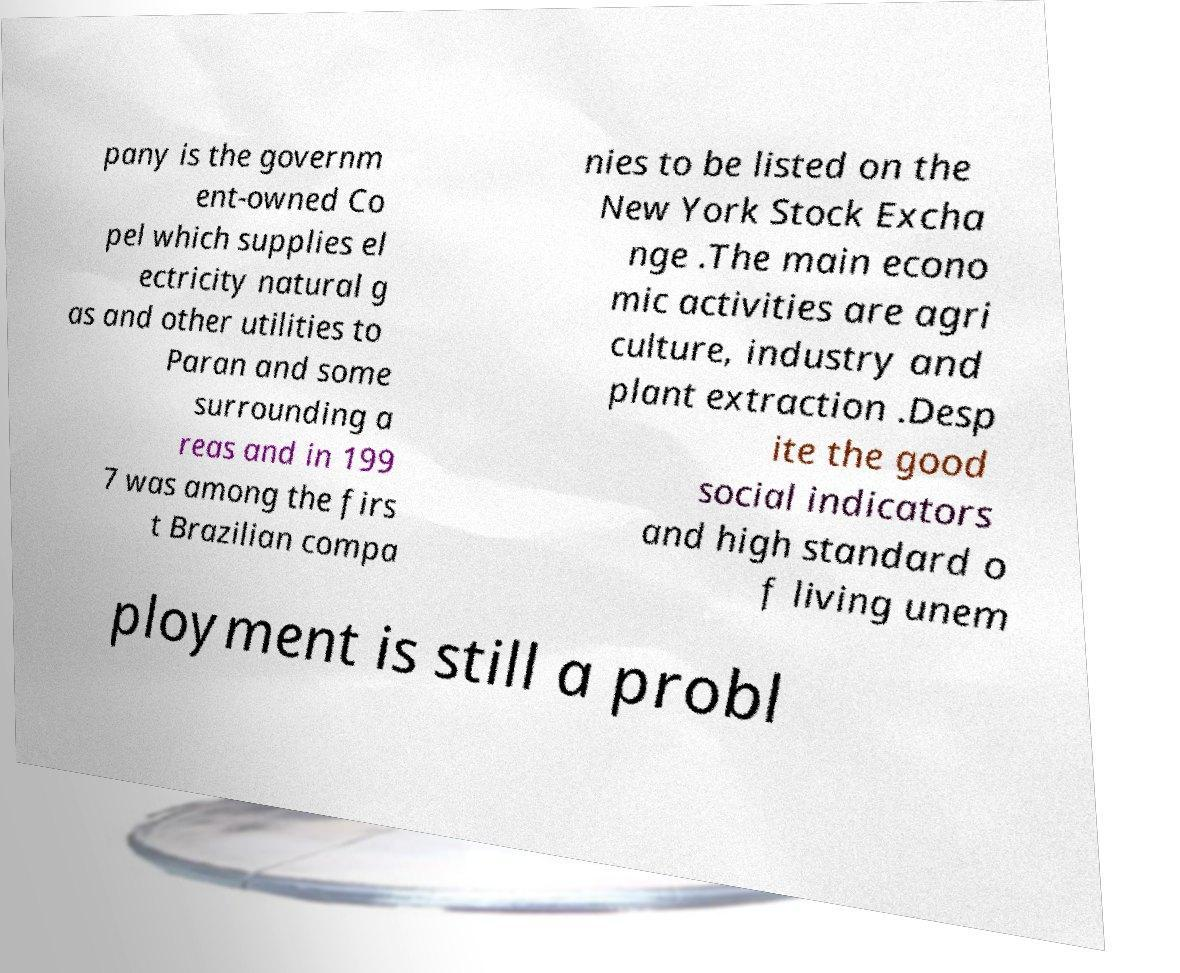Could you assist in decoding the text presented in this image and type it out clearly? pany is the governm ent-owned Co pel which supplies el ectricity natural g as and other utilities to Paran and some surrounding a reas and in 199 7 was among the firs t Brazilian compa nies to be listed on the New York Stock Excha nge .The main econo mic activities are agri culture, industry and plant extraction .Desp ite the good social indicators and high standard o f living unem ployment is still a probl 